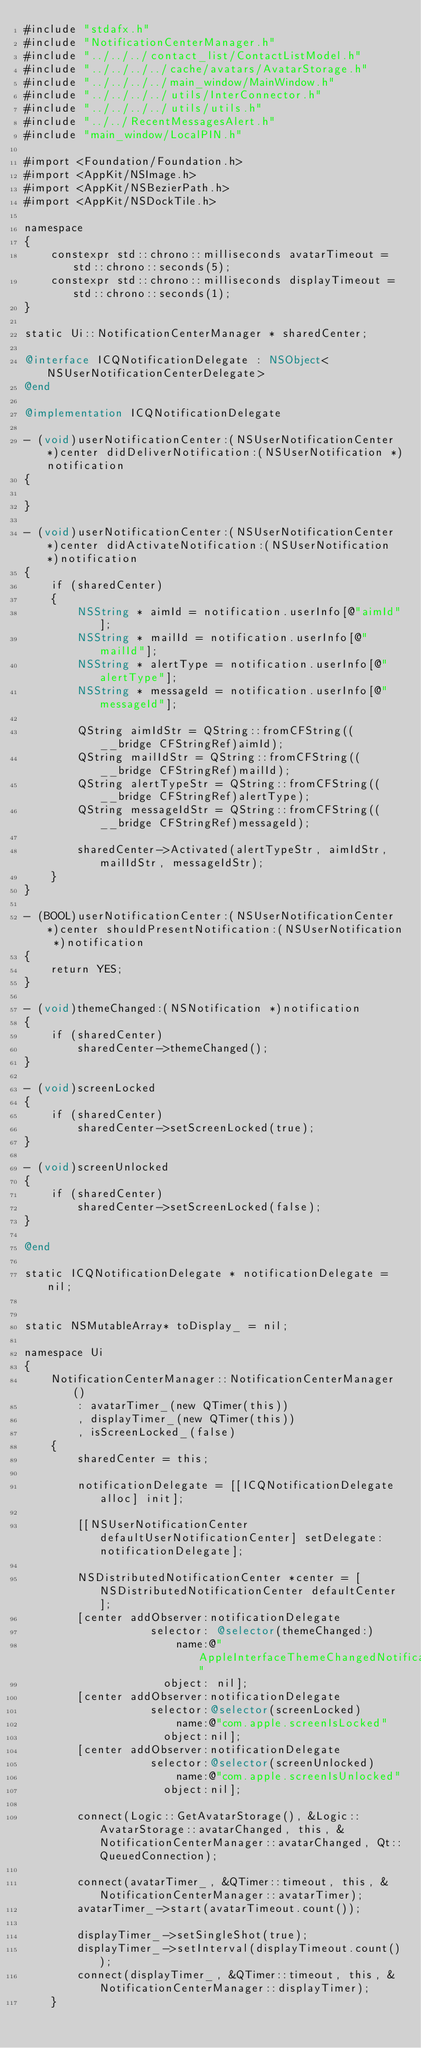Convert code to text. <code><loc_0><loc_0><loc_500><loc_500><_ObjectiveC_>#include "stdafx.h"
#include "NotificationCenterManager.h"
#include "../../../contact_list/ContactListModel.h"
#include "../../../../cache/avatars/AvatarStorage.h"
#include "../../../../main_window/MainWindow.h"
#include "../../../../utils/InterConnector.h"
#include "../../../../utils/utils.h"
#include "../../RecentMessagesAlert.h"
#include "main_window/LocalPIN.h"

#import <Foundation/Foundation.h>
#import <AppKit/NSImage.h>
#import <AppKit/NSBezierPath.h>
#import <AppKit/NSDockTile.h>

namespace
{
    constexpr std::chrono::milliseconds avatarTimeout = std::chrono::seconds(5);
    constexpr std::chrono::milliseconds displayTimeout = std::chrono::seconds(1);
}

static Ui::NotificationCenterManager * sharedCenter;

@interface ICQNotificationDelegate : NSObject<NSUserNotificationCenterDelegate>
@end

@implementation ICQNotificationDelegate

- (void)userNotificationCenter:(NSUserNotificationCenter *)center didDeliverNotification:(NSUserNotification *)notification
{

}

- (void)userNotificationCenter:(NSUserNotificationCenter *)center didActivateNotification:(NSUserNotification *)notification
{
    if (sharedCenter)
    {
        NSString * aimId = notification.userInfo[@"aimId"];
        NSString * mailId = notification.userInfo[@"mailId"];
        NSString * alertType = notification.userInfo[@"alertType"];
        NSString * messageId = notification.userInfo[@"messageId"];

        QString aimIdStr = QString::fromCFString((__bridge CFStringRef)aimId);
        QString mailIdStr = QString::fromCFString((__bridge CFStringRef)mailId);
        QString alertTypeStr = QString::fromCFString((__bridge CFStringRef)alertType);
        QString messageIdStr = QString::fromCFString((__bridge CFStringRef)messageId);

        sharedCenter->Activated(alertTypeStr, aimIdStr, mailIdStr, messageIdStr);
    }
}

- (BOOL)userNotificationCenter:(NSUserNotificationCenter *)center shouldPresentNotification:(NSUserNotification *)notification
{
    return YES;
}

- (void)themeChanged:(NSNotification *)notification
{
    if (sharedCenter)
        sharedCenter->themeChanged();
}

- (void)screenLocked
{
    if (sharedCenter)
        sharedCenter->setScreenLocked(true);
}

- (void)screenUnlocked
{
    if (sharedCenter)
        sharedCenter->setScreenLocked(false);
}

@end

static ICQNotificationDelegate * notificationDelegate = nil;


static NSMutableArray* toDisplay_ = nil;

namespace Ui
{
    NotificationCenterManager::NotificationCenterManager()
        : avatarTimer_(new QTimer(this))
        , displayTimer_(new QTimer(this))
        , isScreenLocked_(false)
    {
        sharedCenter = this;

        notificationDelegate = [[ICQNotificationDelegate alloc] init];

        [[NSUserNotificationCenter defaultUserNotificationCenter] setDelegate:notificationDelegate];

        NSDistributedNotificationCenter *center = [NSDistributedNotificationCenter defaultCenter];
        [center addObserver:notificationDelegate
                   selector: @selector(themeChanged:)
                       name:@"AppleInterfaceThemeChangedNotification"
                     object: nil];
        [center addObserver:notificationDelegate
                   selector:@selector(screenLocked)
                       name:@"com.apple.screenIsLocked"
                     object:nil];
        [center addObserver:notificationDelegate
                   selector:@selector(screenUnlocked)
                       name:@"com.apple.screenIsUnlocked"
                     object:nil];

        connect(Logic::GetAvatarStorage(), &Logic::AvatarStorage::avatarChanged, this, &NotificationCenterManager::avatarChanged, Qt::QueuedConnection);

        connect(avatarTimer_, &QTimer::timeout, this, &NotificationCenterManager::avatarTimer);
        avatarTimer_->start(avatarTimeout.count());

        displayTimer_->setSingleShot(true);
        displayTimer_->setInterval(displayTimeout.count());
        connect(displayTimer_, &QTimer::timeout, this, &NotificationCenterManager::displayTimer);
    }
</code> 